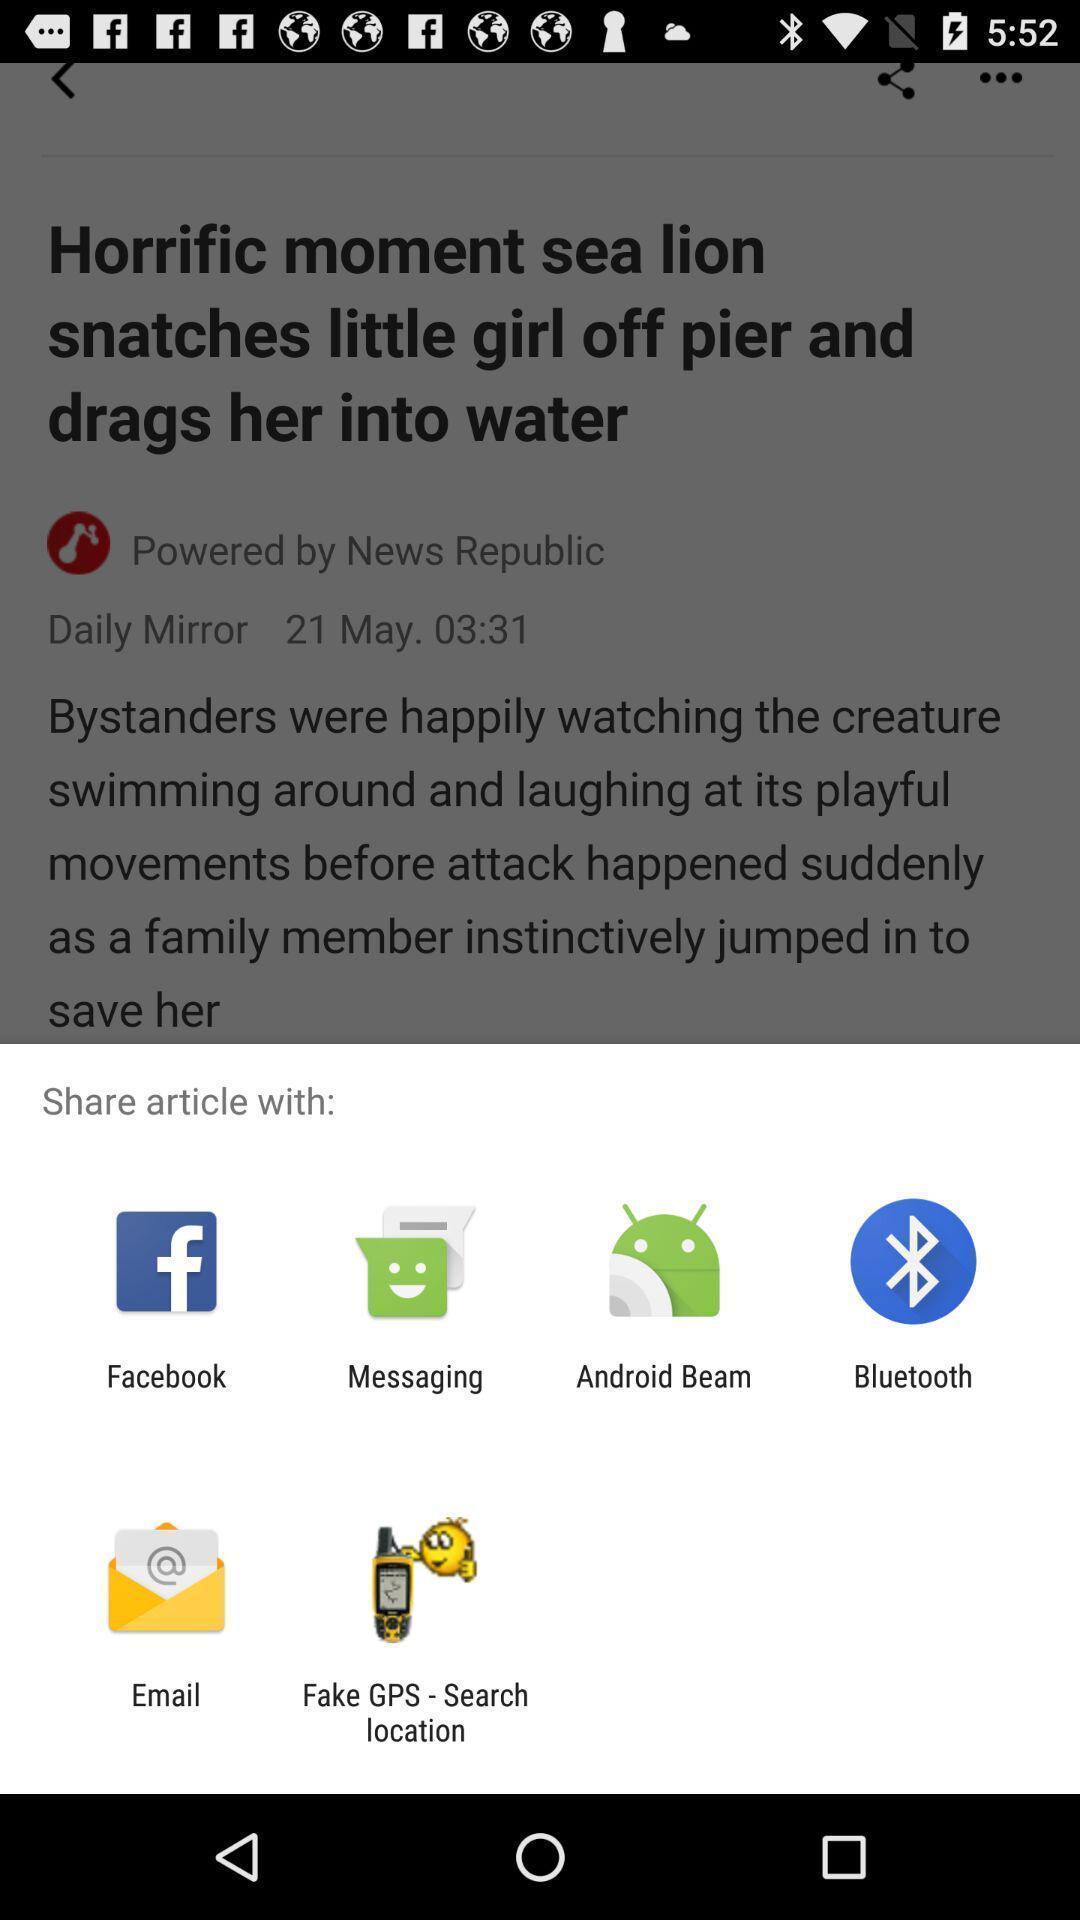Explain the elements present in this screenshot. Popup to share an article from the news browser. 